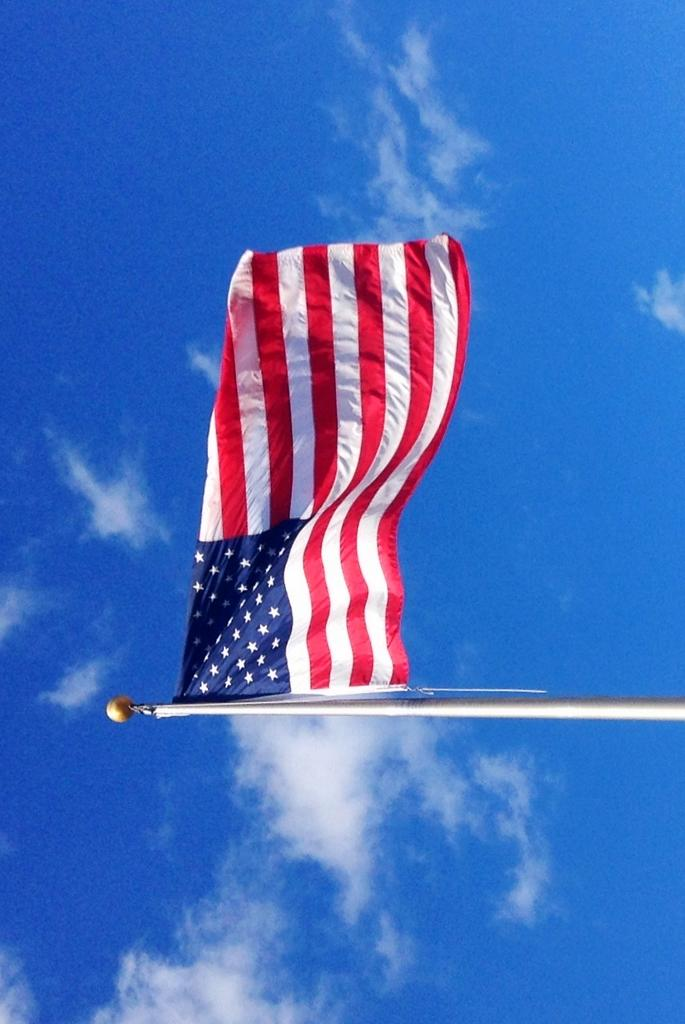What is the main object in the image? There is a flag in the image. How is the flag supported or held up? The flag is attached to a stand. What can be seen in the background of the image? The sky is visible in the image. How many toes can be seen on the glass in the image? There is no glass or toes present in the image; it features a flag attached to a stand with the sky visible in the background. 